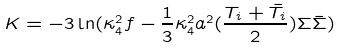Convert formula to latex. <formula><loc_0><loc_0><loc_500><loc_500>K = - 3 \ln ( \kappa _ { 4 } ^ { 2 } f - \frac { 1 } { 3 } \kappa _ { 4 } ^ { 2 } a ^ { 2 } ( \frac { T _ { i } + \bar { T } _ { i } } { 2 } ) \Sigma \bar { \Sigma } )</formula> 